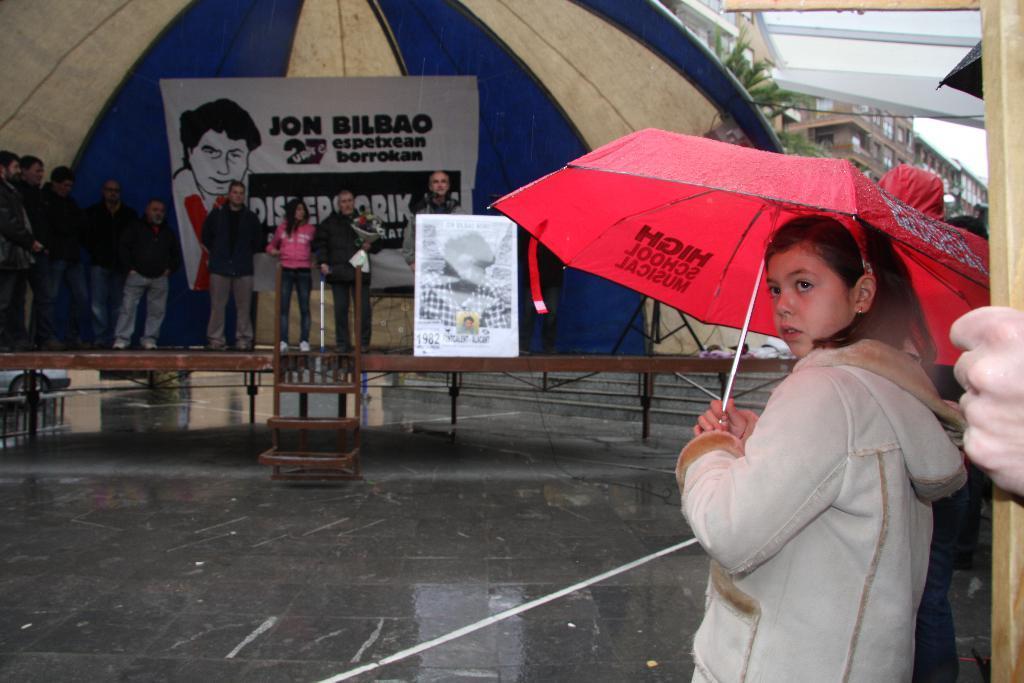In one or two sentences, can you explain what this image depicts? In this picture I can see a girl holding an umbrella on the right side. In the middle a group of people are standing on the stage, there is a banner in the background. In the top right hand side I can see the trees and buildings. 